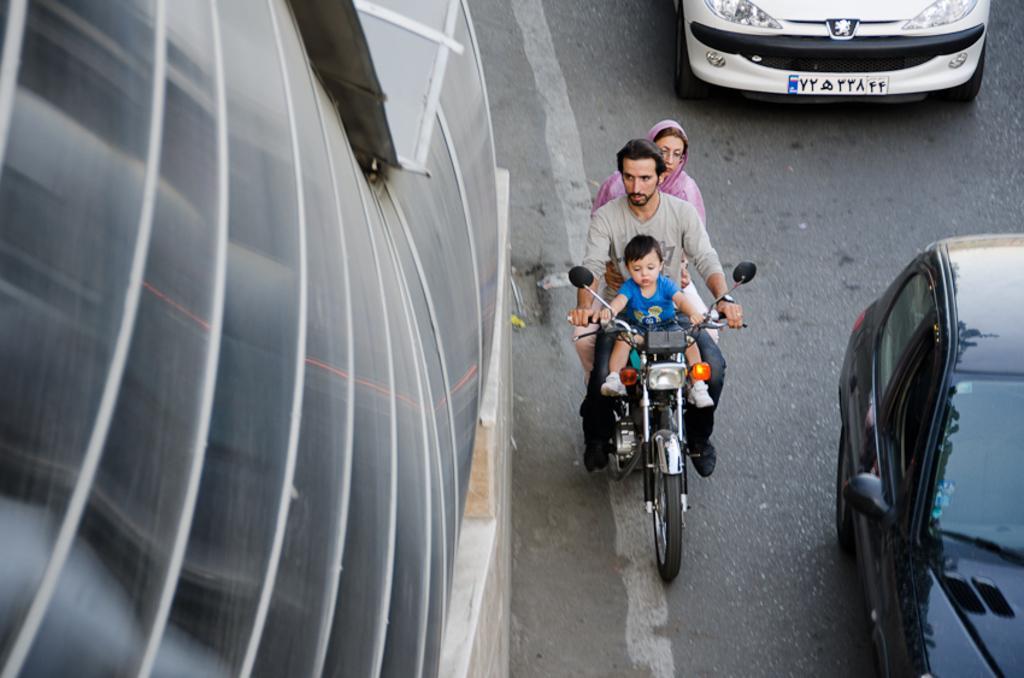Can you describe this image briefly? In this image I can see three persons on the bike and I can see few vehicles on the road and I can see a glass building. 